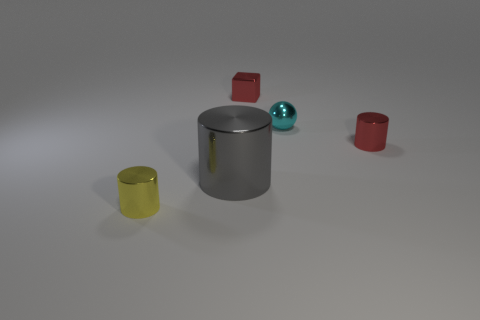There is a small metal object that is the same color as the small cube; what is its shape?
Your response must be concise. Cylinder. There is a cyan thing; what shape is it?
Your answer should be compact. Sphere. Is the number of balls left of the cyan thing less than the number of small metallic blocks?
Your response must be concise. Yes. Is there a tiny green matte object that has the same shape as the small cyan object?
Provide a short and direct response. No. The cyan metal object that is the same size as the red cylinder is what shape?
Ensure brevity in your answer.  Sphere. How many things are tiny red cubes or small yellow things?
Make the answer very short. 2. Is there a tiny red metallic cube?
Give a very brief answer. Yes. Are there fewer tiny red things than tiny cyan metal things?
Provide a short and direct response. No. Are there any gray spheres that have the same size as the red metallic cube?
Make the answer very short. No. Is the shape of the small cyan object the same as the large gray shiny thing that is in front of the tiny metal block?
Keep it short and to the point. No. 